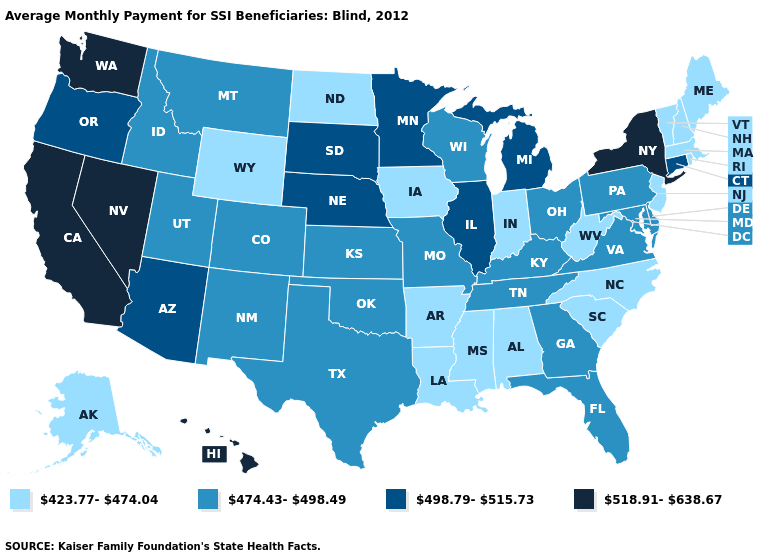What is the value of Tennessee?
Give a very brief answer. 474.43-498.49. Name the states that have a value in the range 423.77-474.04?
Keep it brief. Alabama, Alaska, Arkansas, Indiana, Iowa, Louisiana, Maine, Massachusetts, Mississippi, New Hampshire, New Jersey, North Carolina, North Dakota, Rhode Island, South Carolina, Vermont, West Virginia, Wyoming. Does Texas have a lower value than Connecticut?
Give a very brief answer. Yes. What is the value of Maine?
Concise answer only. 423.77-474.04. What is the value of Michigan?
Concise answer only. 498.79-515.73. Among the states that border Iowa , does Nebraska have the highest value?
Quick response, please. Yes. Which states have the lowest value in the South?
Quick response, please. Alabama, Arkansas, Louisiana, Mississippi, North Carolina, South Carolina, West Virginia. What is the value of Alabama?
Give a very brief answer. 423.77-474.04. What is the value of Utah?
Be succinct. 474.43-498.49. Name the states that have a value in the range 498.79-515.73?
Answer briefly. Arizona, Connecticut, Illinois, Michigan, Minnesota, Nebraska, Oregon, South Dakota. What is the lowest value in states that border Maine?
Concise answer only. 423.77-474.04. Does Indiana have the lowest value in the MidWest?
Quick response, please. Yes. Name the states that have a value in the range 423.77-474.04?
Give a very brief answer. Alabama, Alaska, Arkansas, Indiana, Iowa, Louisiana, Maine, Massachusetts, Mississippi, New Hampshire, New Jersey, North Carolina, North Dakota, Rhode Island, South Carolina, Vermont, West Virginia, Wyoming. Among the states that border Washington , which have the highest value?
Short answer required. Oregon. Does Montana have a higher value than Alaska?
Be succinct. Yes. 